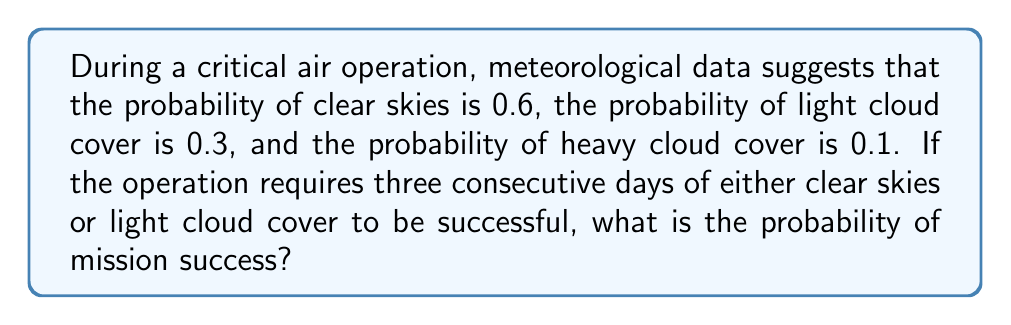Could you help me with this problem? Let's approach this step-by-step:

1) First, we need to calculate the probability of having weather conditions suitable for the operation on a single day. This includes both clear skies and light cloud cover:

   $P(\text{suitable weather}) = P(\text{clear}) + P(\text{light clouds}) = 0.6 + 0.3 = 0.9$

2) Now, we need the probability of having suitable weather for three consecutive days. Since each day's weather is independent, we can multiply the probabilities:

   $P(\text{3 days suitable}) = 0.9 \times 0.9 \times 0.9 = 0.9^3$

3) Let's calculate this:

   $0.9^3 = 0.729$

Therefore, the probability of mission success is 0.729 or 72.9%.

This calculation assumes independence of daily weather conditions, which is a simplification. In reality, weather patterns often show correlation over consecutive days, which would require a more complex model to accurately represent.
Answer: 0.729 